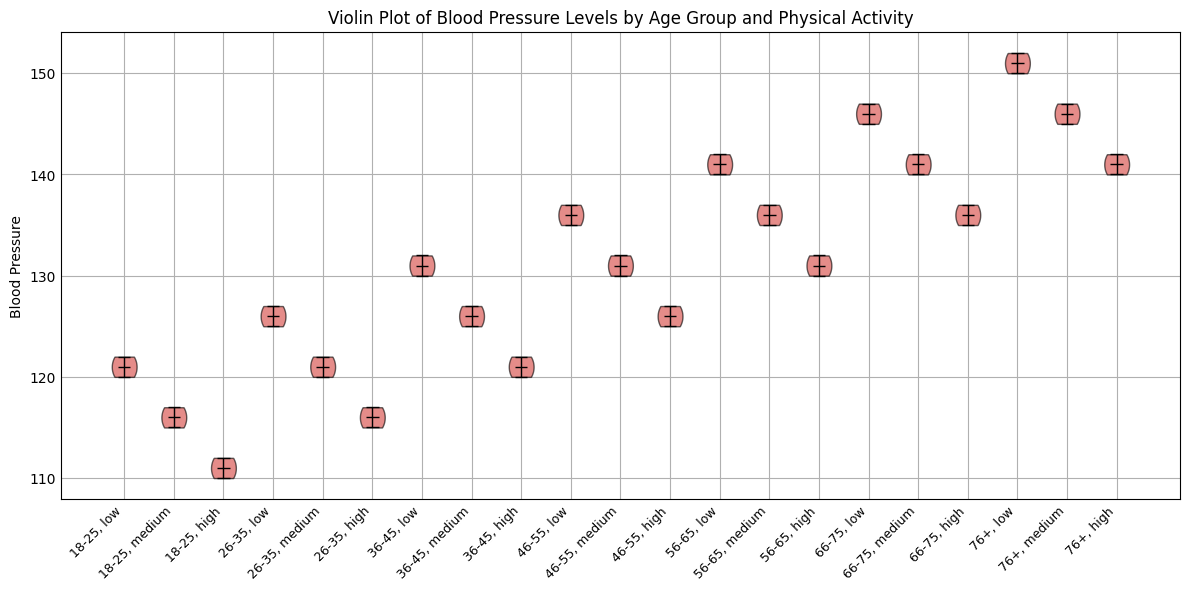What age group has the highest median blood pressure at high physical activity levels? The group '76+' with high physical activity level has the highest median blood pressure level among all other corresponding groups. This is indicated by the top position of the median line in the violin representing the '76+, high' category compared to other high physical activity groups.
Answer: 76+ Which age group shows the largest range of blood pressure values for the medium physical activity level? By observing the height of each violin plot for medium physical activity levels, the '76+' age group shows the largest range. This is evident as the length of the '76+, medium' violin is longer compared to other medium activity groups, indicating a wider distribution of blood pressure values.
Answer: 76+ How does the median blood pressure for the '36-45' age group at low physical activity level compare to the '76+' age group at high physical activity level? The median blood pressure of the '36-45' age group at low physical activity is lower than that of the '76+' group at high physical activity. This can be seen by comparing the position of the respective median lines, where '36-45, low' median line is noticeably lower than the '76+, high' median line.
Answer: Lower In which age group does high physical activity have the smallest reducing effect on blood pressure compared to low physical activity? The '18-25' age group shows the smallest reducing effect of high physical activity on blood pressure compared to low physical activity. This is evident as the difference in medians between 'low' and 'high' physical activity levels within this age group is relatively smaller compared to other groups.
Answer: 18-25 What visual pattern is observed for the relationship between age and blood pressure across different physical activity levels? As age increases, the blood pressure values tend to increase regardless of the physical activity level. This pattern is evident from the upward shift in the medians of the violin plots as you move from younger to older age groups for each physical activity level (low, medium, and high).
Answer: Blood pressure increases with age Which physical activity level has the lowest median blood pressure for the '46-55' age group? The 'high' physical activity level has the lowest median blood pressure for the '46-55' age group. This can be observed from the median lines within the '46-55' category, where the median for high physical activity is at the lowest position compared to low and medium.
Answer: High Is there any physical activity level where the median blood pressure for the '66-75' age group is higher than all physical activity levels of the '36-45' age group? Yes, the median blood pressure for the '66-75' age group at low physical activity level is higher than all physical activity levels of the '36-45' age group. This is evident by comparing the respective medians and noting that '66-75, low' has a higher median compared to any '36-45' activity level.
Answer: Yes Which combination of age group and physical activity level displays the smallest range of blood pressure values? The '18-25' age group at high physical activity level displays the smallest range of blood pressure values. This can be determined by observing the length of the '18-25, high' violin plot, which is shorter than others, indicating a smaller range.
Answer: 18-25, high 